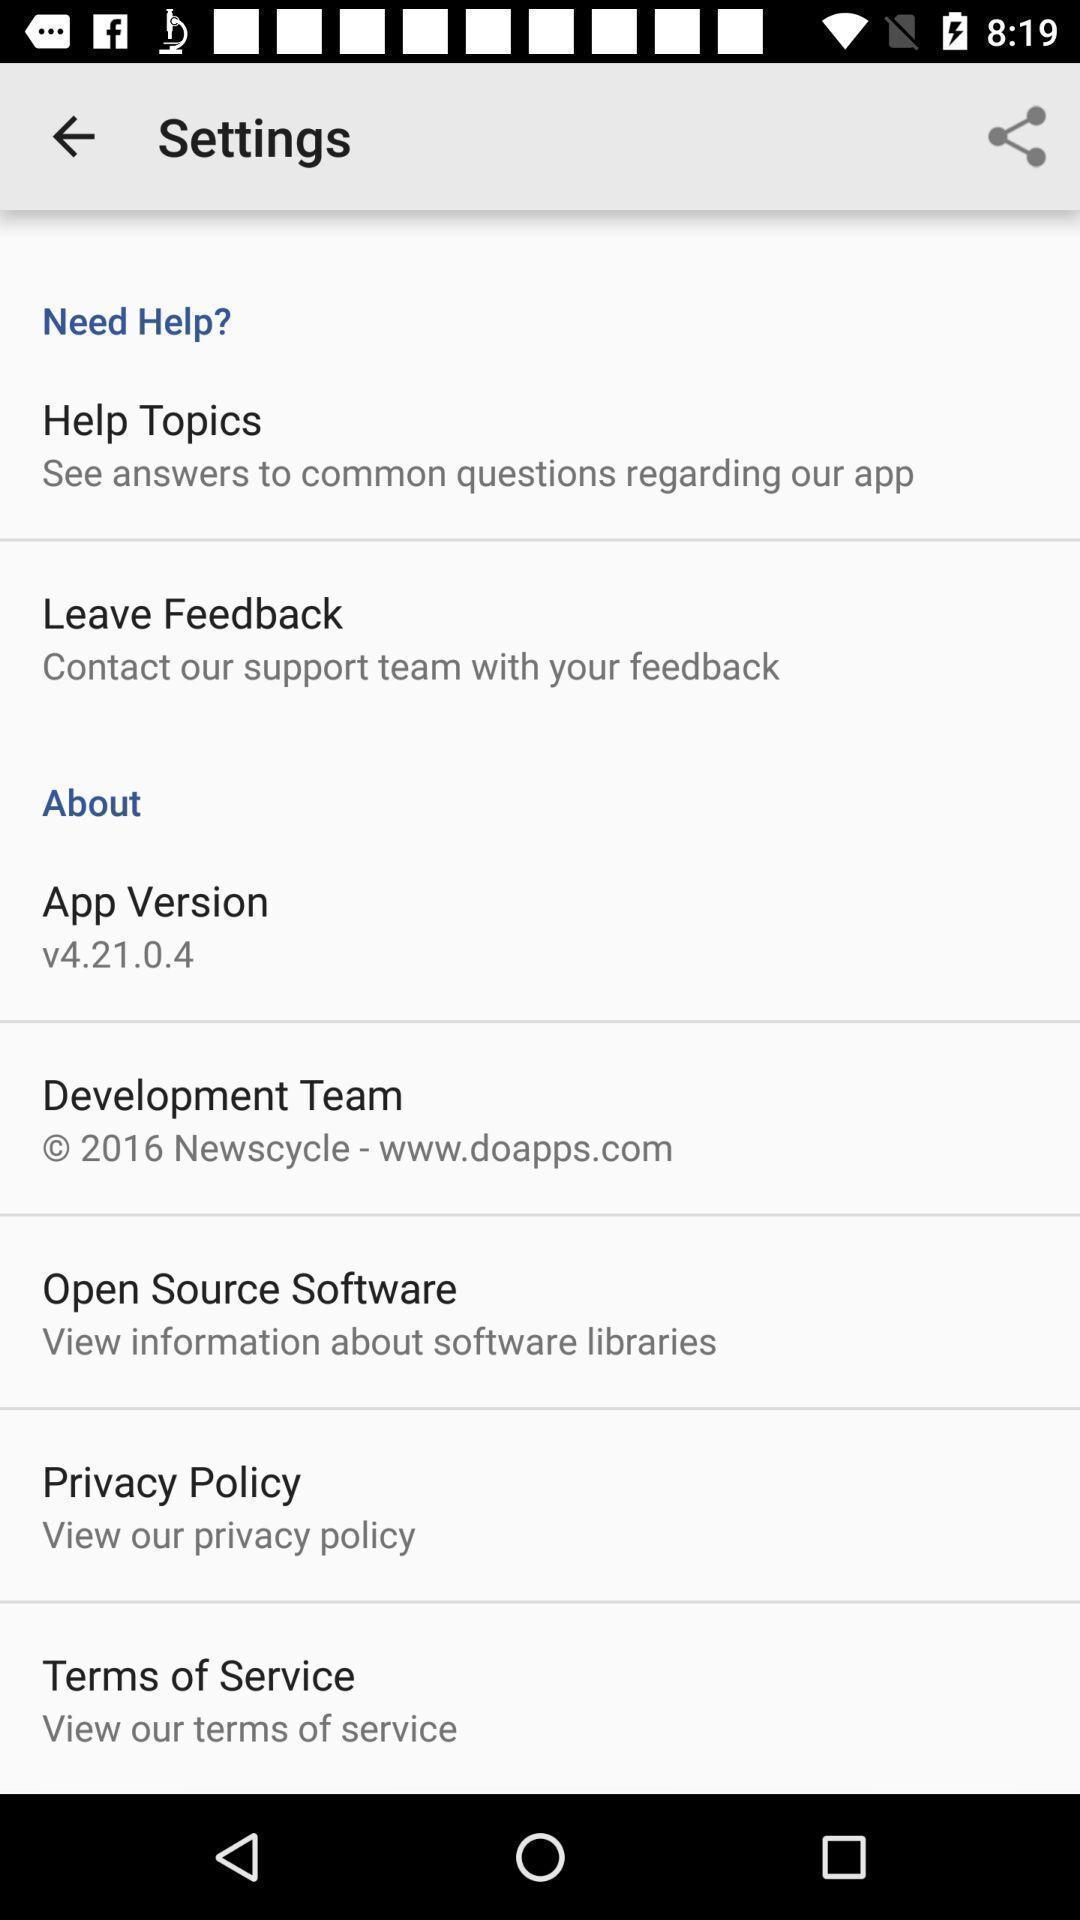Summarize the main components in this picture. Screen is showing settings page. 